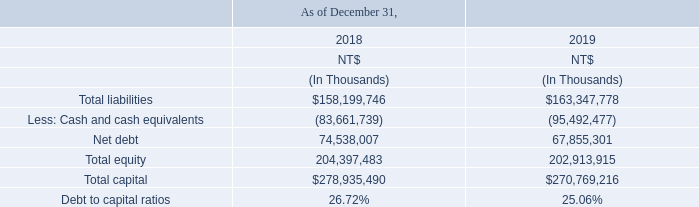CAPITAL MANAGEMENT
The primary objective of the Company’s capital management is to ensure that it maintains a strong credit rating and healthy capital ratios to support its business and maximize the stockholders’ value. The Company also ensures its ability to operate continuously to provide returns to stockholders and the interests of other related parties, while maintaining the optimal capital structure to reduce costs of capital.
To maintain or adjust the capital structure, the Company may adjust the dividend payment to stockholders, return capital to stockholders, issue new shares or dispose assets to redeem liabilities.
Similar to its peers, the Company monitors its capital based on debt to capital ratio. The ratio is calculated as the Company’s net debt divided by its total capital. The net debt is derived by taking the total liabilities on the consolidated balance sheets minus cash and cash equivalents. The total capital consists of total equity (including capital, additional paid-in capital, retained earnings, other components of equity and non-controlling interests) plus net debt.
The Company’s strategy, which is unchanged for the reporting periods, is to maintain a reasonable ratio in order to raise capital with reasonable cost. The debt to capital ratios as of December 31, 2018 and 2019 were as follows:
What is The primary objective of the Company’s capital management? The primary objective of the company’s capital management is to ensure that it maintains a strong credit rating and healthy capital ratios to support its business and maximize the stockholders’ value. the company also ensures its ability to operate continuously to provide returns to stockholders and the interests of other related parties, while maintaining the optimal capital structure to reduce costs of capital. What steps does the company take To maintain or adjust the capital structure? The company may adjust the dividend payment to stockholders, return capital to stockholders, issue new shares or dispose assets to redeem liabilities. What is the company's strategy? The company’s strategy, which is unchanged for the reporting periods, is to maintain a reasonable ratio in order to raise capital with reasonable cost. What is the increase / (decrease) in the Total liabilities from 2018 to 2019?
Answer scale should be: thousand. 163,347,778 - 158,199,746
Answer: 5148032. What is the increase / (decrease) in the Net debt from 2018 to 2019?
Answer scale should be: thousand. 67,855,301 - 74,538,007
Answer: -6682706. What is the percentage increase / (decrease) of Total Capital from 2018 to 2019?
Answer scale should be: percent. 270,769,216 / 278,935,490 - 1
Answer: -2.93. 